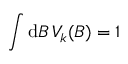<formula> <loc_0><loc_0><loc_500><loc_500>\int d B \, V _ { k } ( B ) = 1</formula> 